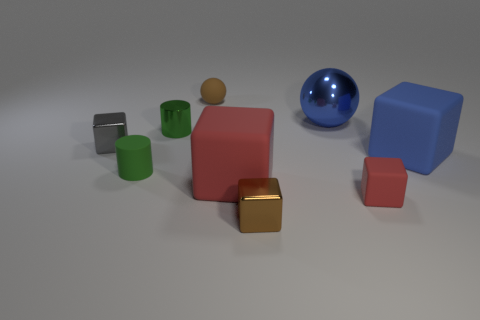The thing that is the same color as the small rubber cube is what size?
Offer a very short reply. Large. There is a blue ball behind the red rubber thing that is on the left side of the brown object in front of the tiny gray metallic block; what is its size?
Your answer should be compact. Large. The gray metal cube is what size?
Give a very brief answer. Small. There is a small metallic block behind the brown thing in front of the green shiny cylinder; is there a big sphere to the left of it?
Your answer should be compact. No. What number of tiny objects are brown metallic balls or matte blocks?
Your response must be concise. 1. Are there any other things that have the same color as the small matte cylinder?
Give a very brief answer. Yes. There is a brown object that is in front of the green rubber thing; is it the same size as the blue matte thing?
Provide a succinct answer. No. There is a matte thing that is behind the metal thing right of the shiny block that is in front of the gray metal object; what color is it?
Offer a terse response. Brown. The big metallic sphere is what color?
Make the answer very short. Blue. Does the small metallic cylinder have the same color as the matte cylinder?
Give a very brief answer. Yes. 